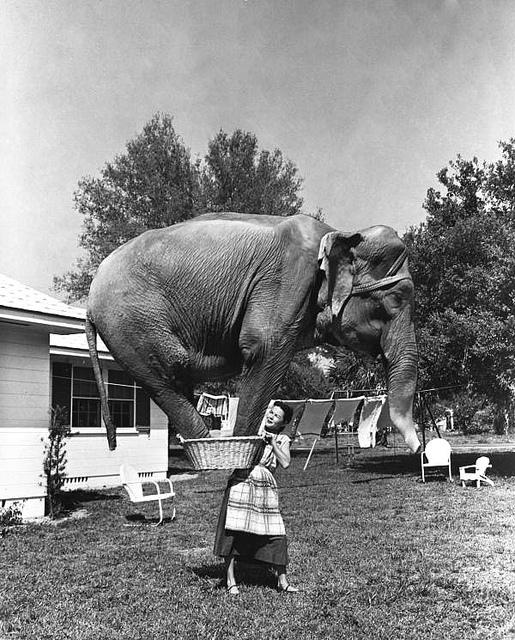What is in the basket?
Answer briefly. Elephant. How many chairs are there?
Keep it brief. 3. Is the woman carrying the elephant?
Write a very short answer. Yes. 